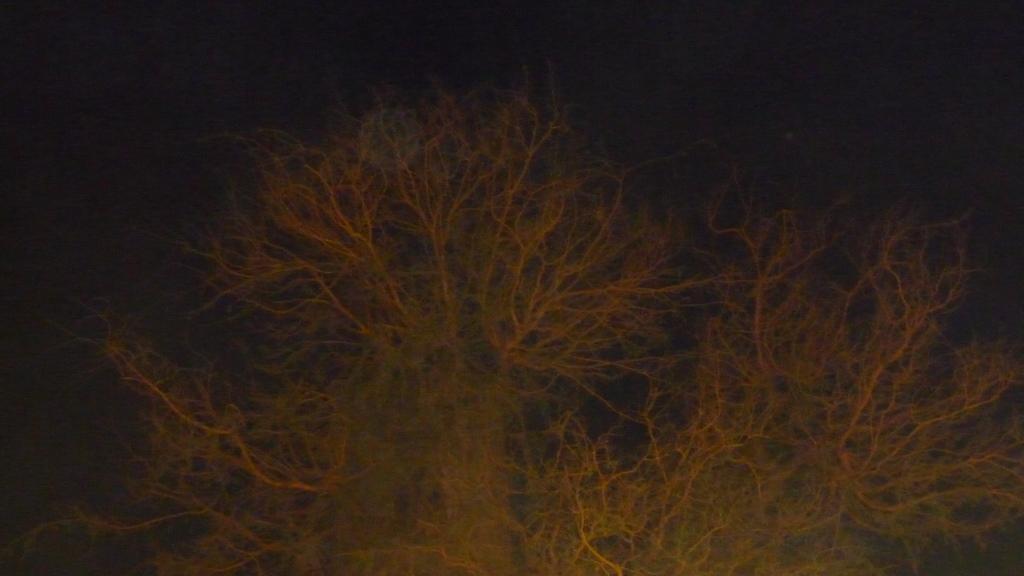How would you summarize this image in a sentence or two? In this image we can see some trees and the background is dark. 